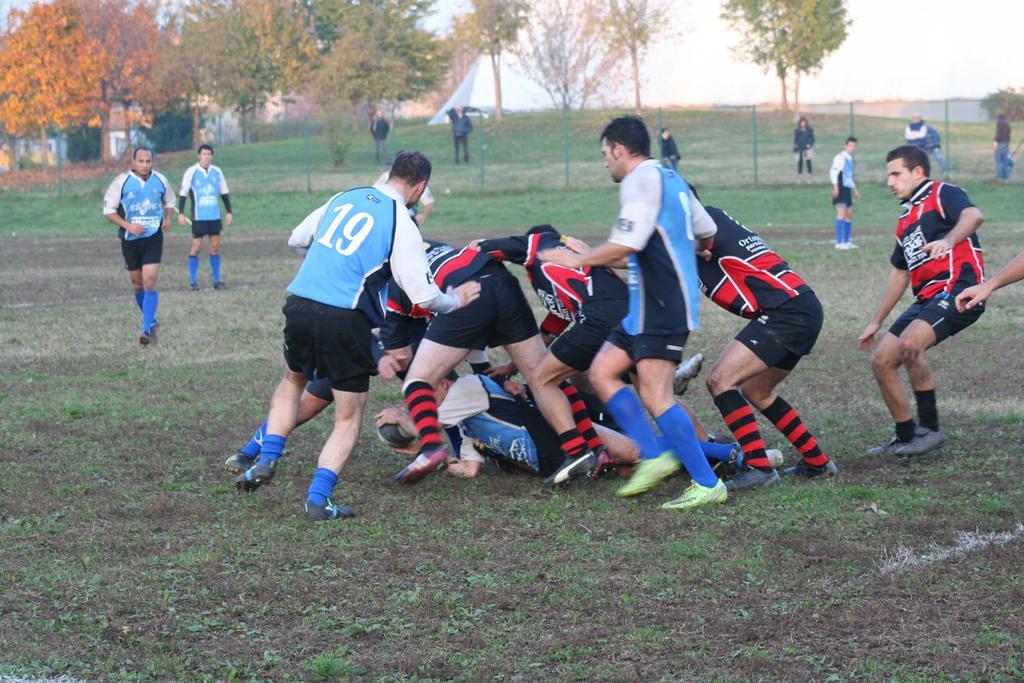Please provide a concise description of this image. In this image I can see the group of people with different color jerseys. These are in blue, white red and black color jerseys. To the side I can see the railing. In the background there are many trees and the sky. 